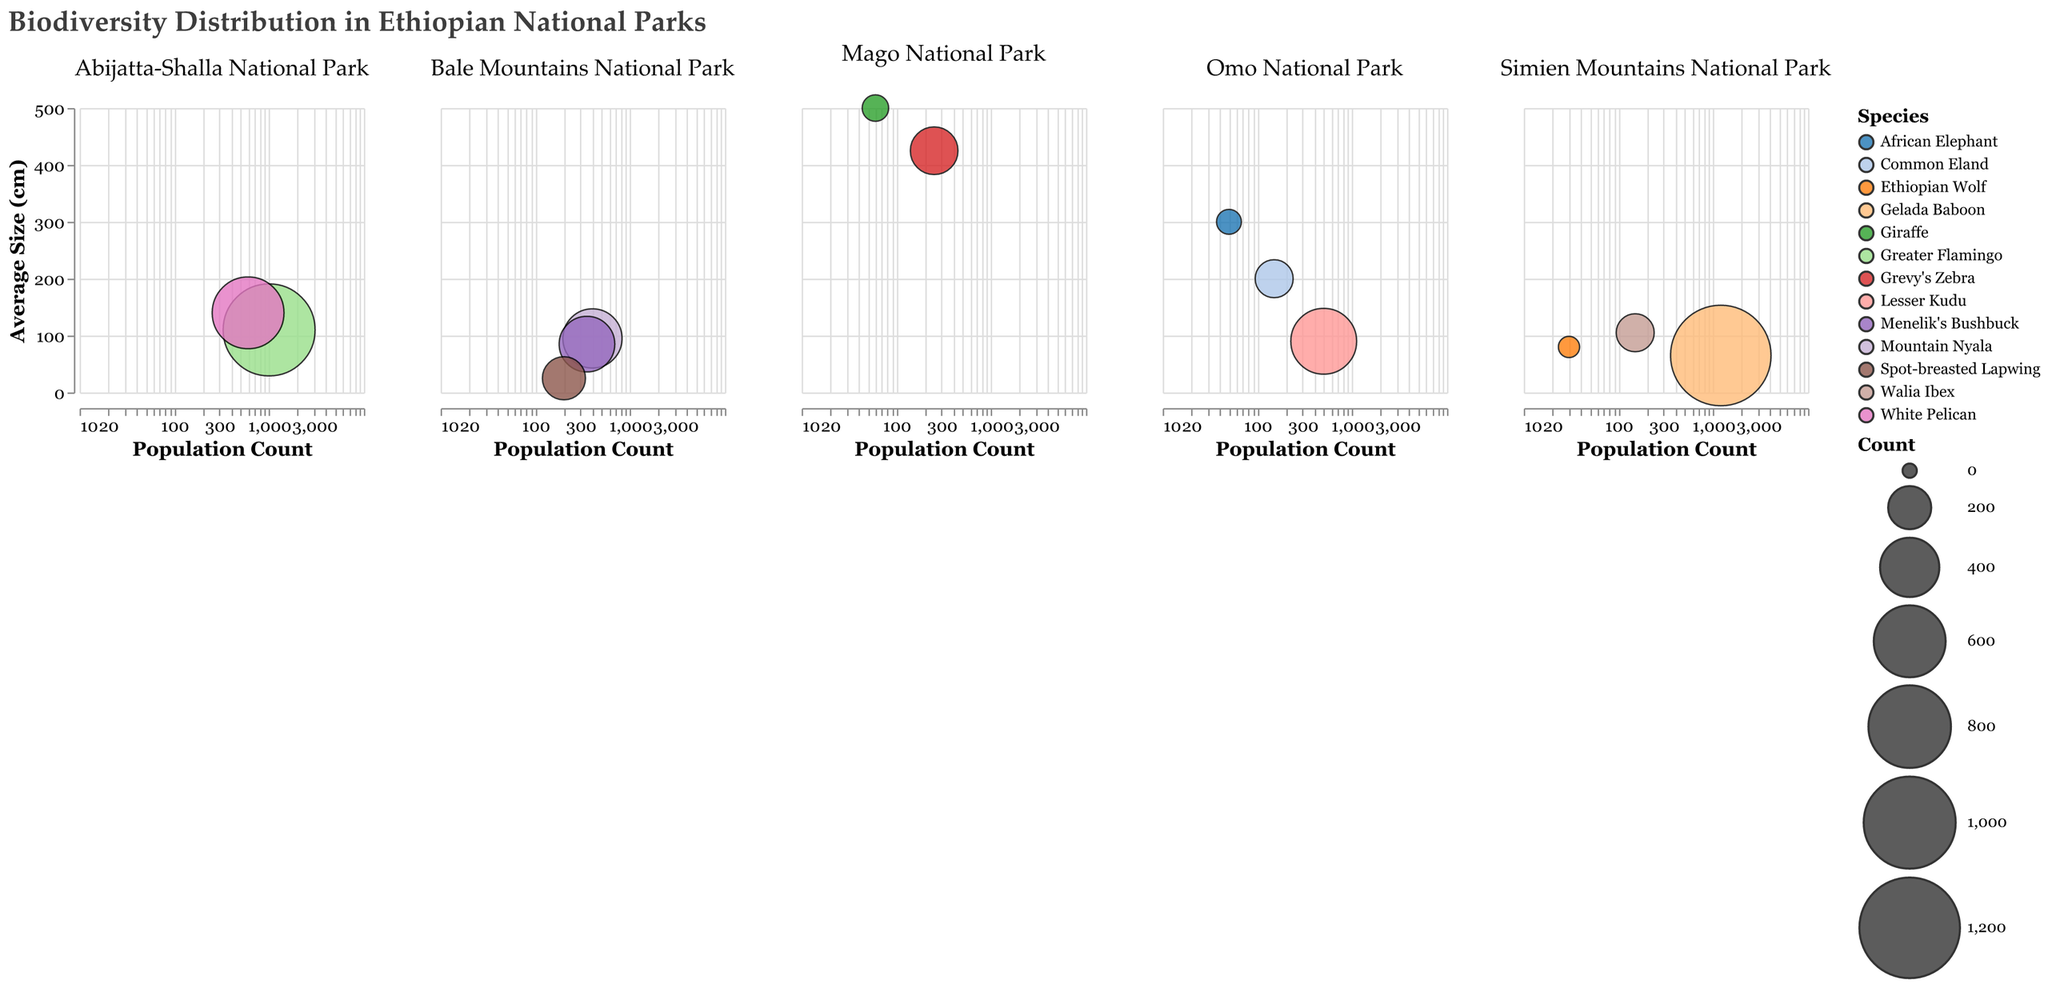What is the title of the figure? The title is placed at the top of the figure and provides a general idea about what the data represents.
Answer: Biodiversity Distribution in Ethiopian National Parks Which national park has the species with the largest average size? By looking at the subplot with the highest "AvgSize" on the y-axis across all parks, it corresponds to the "Giraffe" data point in Mago National Park.
Answer: Mago National Park What is the color representation for the species "Greater Flamingo"? The figure legend or the data points themselves will show the specified color for "Greater Flamingo," which is Crimson.
Answer: Crimson Which species have the highest population count and in which park is it located? By observing the x-axis for the highest population count and identifying the associated color and label, the highest count is 1200 for "Gelada Baboon" in Simien Mountains National Park.
Answer: Gelada Baboon in Simien Mountains National Park Compare the average size of the "White Pelican" and "Greater Flamingo." Which one is larger? The subplot for Abijatta-Shalla National Park shows the data points for "White Pelican" and "Greater Flamingo." By comparing the values on the y-axis, "White Pelican" has an average size of 140, which is larger than the 110 of "Greater Flamingo."
Answer: White Pelican What species in Bale Mountains National Park has the smallest average size? Reading the figure from Bale Mountains National Park subplot, the data point with the lowest y-axis value corresponds to "Spot-breasted Lapwing" with an average size of 25 cm.
Answer: Spot-breasted Lapwing What is the total number of Giraffes in Mago National Park? The figure indicates that there are 60 Giraffes in Mago National Park as stated by the "Count" attribute.
Answer: 60 How does the average size of the "African Elephant" compare to the "Common Eland"? The average size of "African Elephant" (300 cm) in Omo National Park is greater than the "Common Eland" (200 cm) according to the y-axis values.
Answer: African Elephant is larger What species in Abijatta-Shalla National Park has a population size larger than the "Mountain Nyala" in Bale Mountains National Park? "Mountain Nyala" in Bale Mountains National Park has a population count of 400. In the subplot for Abijatta-Shalla National Park, both "Greater Flamingo" (1000) and "White Pelican" (600) exceed this count.
Answer: Greater Flamingo and White Pelican Which park hosts the species with the smallest population count and what is it? The visual representation of the data points shows that the smallest population count is 30 for "Ethiopian Wolf" in Simien Mountains National Park.
Answer: Simien Mountains National Park, Ethiopian Wolf 